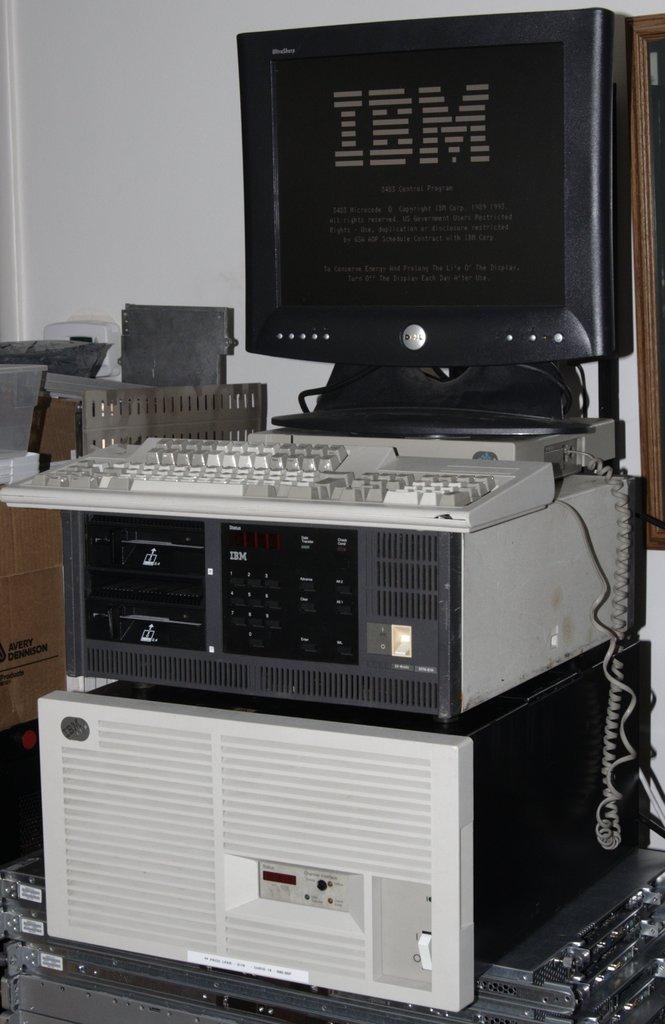What car sponsors this event?
Your answer should be very brief. Unanswerable. What brand of monitor is this?
Your response must be concise. Ibm. 